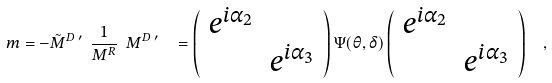Convert formula to latex. <formula><loc_0><loc_0><loc_500><loc_500>m = - \tilde { M } ^ { D } \, ^ { \prime } \ \frac { 1 } { M ^ { R } } \ M ^ { D } \, ^ { \prime } \ \ = \left ( \begin{array} { c c } e ^ { i \alpha _ { 2 } } & \\ & e ^ { i \alpha _ { 3 } } \end{array} \right ) \Psi ( \theta , \delta ) \left ( \begin{array} { c c } e ^ { i \alpha _ { 2 } } & \\ & e ^ { i \alpha _ { 3 } } \end{array} \right ) \ \ ,</formula> 